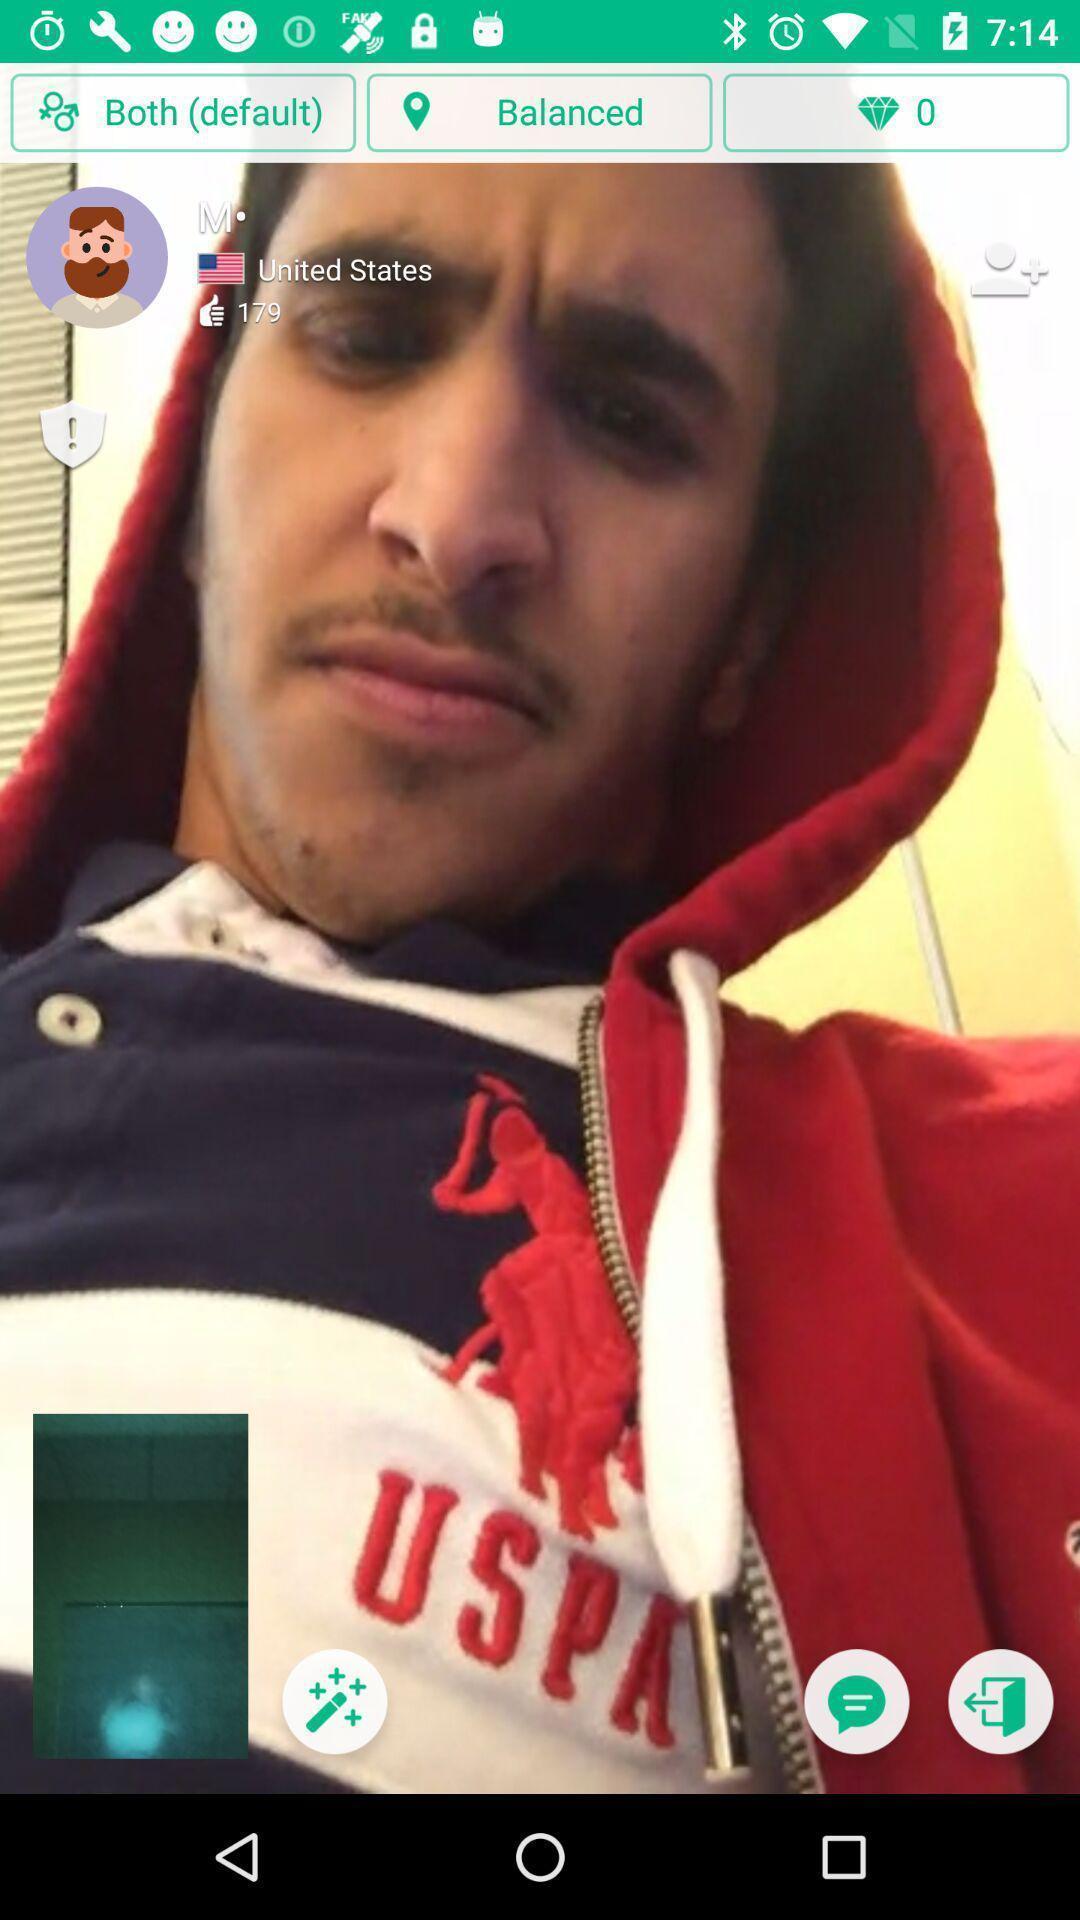Describe this image in words. Screen displaying a video chat. 